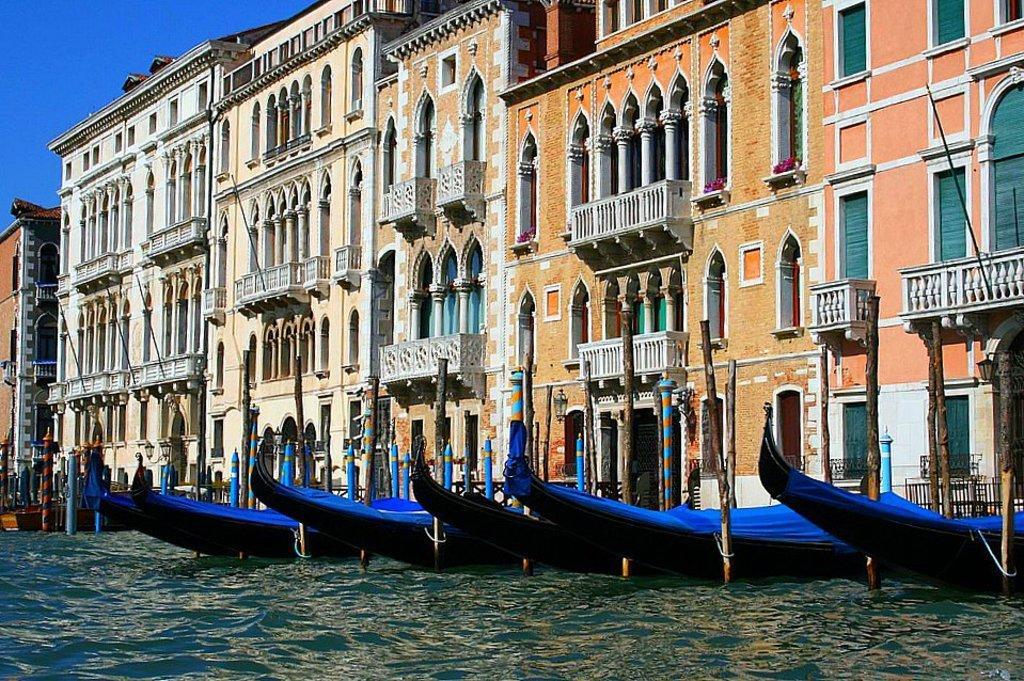Could you give a brief overview of what you see in this image? In this picture there are buildings. In the foreground there are boats on the water and there are wooden poles. At the top there is sky. At the bottom there is water. 